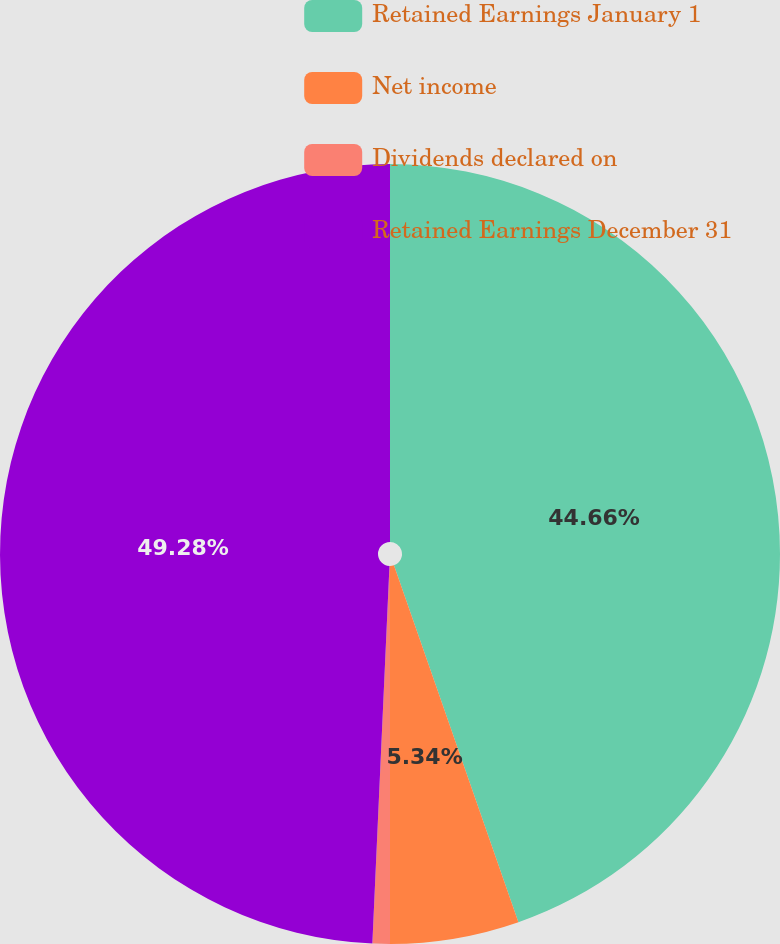<chart> <loc_0><loc_0><loc_500><loc_500><pie_chart><fcel>Retained Earnings January 1<fcel>Net income<fcel>Dividends declared on<fcel>Retained Earnings December 31<nl><fcel>44.66%<fcel>5.34%<fcel>0.72%<fcel>49.28%<nl></chart> 